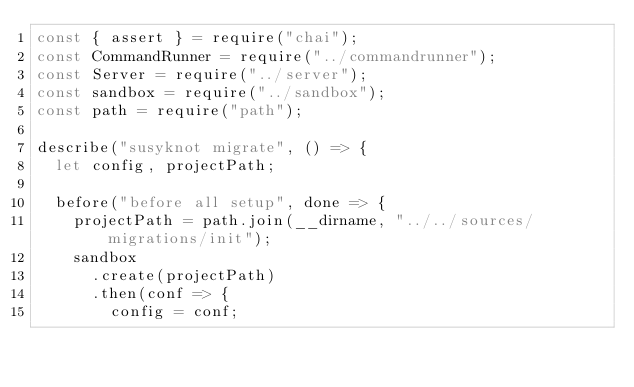Convert code to text. <code><loc_0><loc_0><loc_500><loc_500><_JavaScript_>const { assert } = require("chai");
const CommandRunner = require("../commandrunner");
const Server = require("../server");
const sandbox = require("../sandbox");
const path = require("path");

describe("susyknot migrate", () => {
  let config, projectPath;

  before("before all setup", done => {
    projectPath = path.join(__dirname, "../../sources/migrations/init");
    sandbox
      .create(projectPath)
      .then(conf => {
        config = conf;</code> 